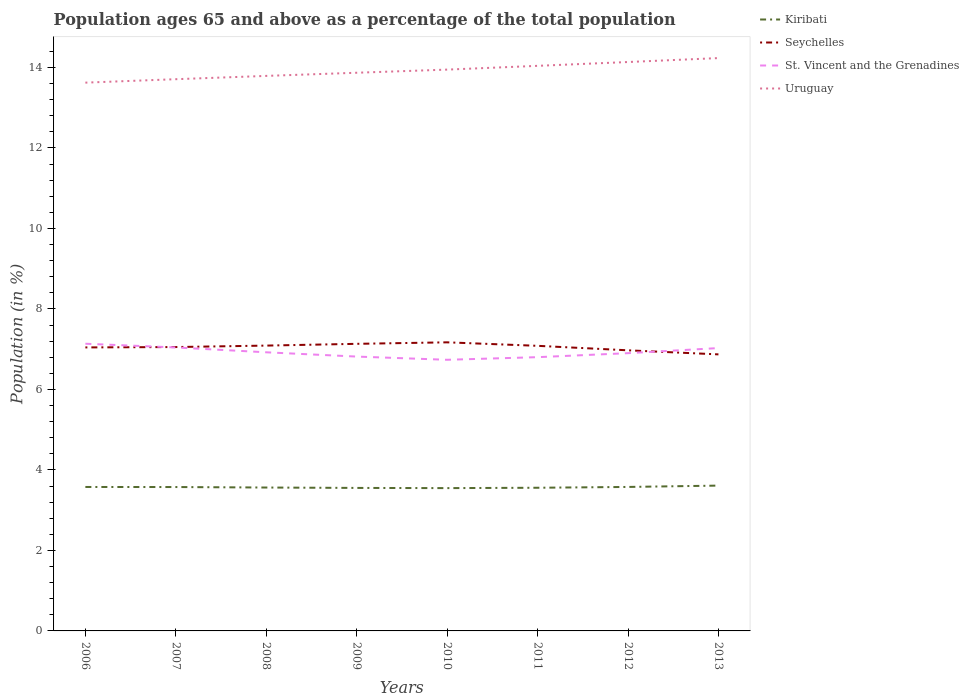Does the line corresponding to St. Vincent and the Grenadines intersect with the line corresponding to Seychelles?
Offer a terse response. Yes. Across all years, what is the maximum percentage of the population ages 65 and above in Seychelles?
Offer a very short reply. 6.87. In which year was the percentage of the population ages 65 and above in Uruguay maximum?
Offer a very short reply. 2006. What is the total percentage of the population ages 65 and above in St. Vincent and the Grenadines in the graph?
Your answer should be very brief. -0.21. What is the difference between the highest and the second highest percentage of the population ages 65 and above in Kiribati?
Make the answer very short. 0.06. Is the percentage of the population ages 65 and above in Uruguay strictly greater than the percentage of the population ages 65 and above in Seychelles over the years?
Offer a very short reply. No. How many lines are there?
Offer a terse response. 4. Does the graph contain grids?
Keep it short and to the point. No. Where does the legend appear in the graph?
Keep it short and to the point. Top right. How many legend labels are there?
Keep it short and to the point. 4. How are the legend labels stacked?
Make the answer very short. Vertical. What is the title of the graph?
Keep it short and to the point. Population ages 65 and above as a percentage of the total population. Does "Canada" appear as one of the legend labels in the graph?
Offer a terse response. No. What is the label or title of the X-axis?
Provide a short and direct response. Years. What is the Population (in %) of Kiribati in 2006?
Your answer should be very brief. 3.58. What is the Population (in %) in Seychelles in 2006?
Give a very brief answer. 7.04. What is the Population (in %) in St. Vincent and the Grenadines in 2006?
Your answer should be compact. 7.14. What is the Population (in %) of Uruguay in 2006?
Offer a terse response. 13.62. What is the Population (in %) in Kiribati in 2007?
Give a very brief answer. 3.57. What is the Population (in %) of Seychelles in 2007?
Offer a terse response. 7.05. What is the Population (in %) of St. Vincent and the Grenadines in 2007?
Offer a very short reply. 7.04. What is the Population (in %) of Uruguay in 2007?
Offer a terse response. 13.71. What is the Population (in %) in Kiribati in 2008?
Ensure brevity in your answer.  3.56. What is the Population (in %) in Seychelles in 2008?
Keep it short and to the point. 7.09. What is the Population (in %) of St. Vincent and the Grenadines in 2008?
Your answer should be very brief. 6.92. What is the Population (in %) in Uruguay in 2008?
Make the answer very short. 13.79. What is the Population (in %) in Kiribati in 2009?
Ensure brevity in your answer.  3.55. What is the Population (in %) in Seychelles in 2009?
Provide a succinct answer. 7.13. What is the Population (in %) of St. Vincent and the Grenadines in 2009?
Make the answer very short. 6.82. What is the Population (in %) in Uruguay in 2009?
Ensure brevity in your answer.  13.87. What is the Population (in %) of Kiribati in 2010?
Offer a very short reply. 3.55. What is the Population (in %) of Seychelles in 2010?
Ensure brevity in your answer.  7.17. What is the Population (in %) of St. Vincent and the Grenadines in 2010?
Your response must be concise. 6.74. What is the Population (in %) of Uruguay in 2010?
Ensure brevity in your answer.  13.95. What is the Population (in %) of Kiribati in 2011?
Offer a very short reply. 3.56. What is the Population (in %) in Seychelles in 2011?
Offer a terse response. 7.08. What is the Population (in %) of St. Vincent and the Grenadines in 2011?
Offer a terse response. 6.8. What is the Population (in %) in Uruguay in 2011?
Offer a very short reply. 14.04. What is the Population (in %) of Kiribati in 2012?
Offer a terse response. 3.58. What is the Population (in %) of Seychelles in 2012?
Give a very brief answer. 6.97. What is the Population (in %) in St. Vincent and the Grenadines in 2012?
Keep it short and to the point. 6.9. What is the Population (in %) in Uruguay in 2012?
Give a very brief answer. 14.13. What is the Population (in %) in Kiribati in 2013?
Your response must be concise. 3.61. What is the Population (in %) in Seychelles in 2013?
Provide a short and direct response. 6.87. What is the Population (in %) in St. Vincent and the Grenadines in 2013?
Make the answer very short. 7.03. What is the Population (in %) in Uruguay in 2013?
Give a very brief answer. 14.23. Across all years, what is the maximum Population (in %) of Kiribati?
Keep it short and to the point. 3.61. Across all years, what is the maximum Population (in %) in Seychelles?
Offer a very short reply. 7.17. Across all years, what is the maximum Population (in %) in St. Vincent and the Grenadines?
Give a very brief answer. 7.14. Across all years, what is the maximum Population (in %) in Uruguay?
Keep it short and to the point. 14.23. Across all years, what is the minimum Population (in %) of Kiribati?
Your answer should be compact. 3.55. Across all years, what is the minimum Population (in %) in Seychelles?
Your answer should be compact. 6.87. Across all years, what is the minimum Population (in %) of St. Vincent and the Grenadines?
Offer a terse response. 6.74. Across all years, what is the minimum Population (in %) in Uruguay?
Give a very brief answer. 13.62. What is the total Population (in %) in Kiribati in the graph?
Offer a very short reply. 28.56. What is the total Population (in %) of Seychelles in the graph?
Your answer should be compact. 56.41. What is the total Population (in %) of St. Vincent and the Grenadines in the graph?
Provide a short and direct response. 55.38. What is the total Population (in %) of Uruguay in the graph?
Offer a terse response. 111.34. What is the difference between the Population (in %) in Kiribati in 2006 and that in 2007?
Your answer should be compact. 0. What is the difference between the Population (in %) in Seychelles in 2006 and that in 2007?
Your response must be concise. -0.01. What is the difference between the Population (in %) in St. Vincent and the Grenadines in 2006 and that in 2007?
Provide a short and direct response. 0.09. What is the difference between the Population (in %) in Uruguay in 2006 and that in 2007?
Make the answer very short. -0.09. What is the difference between the Population (in %) in Kiribati in 2006 and that in 2008?
Keep it short and to the point. 0.01. What is the difference between the Population (in %) of Seychelles in 2006 and that in 2008?
Give a very brief answer. -0.05. What is the difference between the Population (in %) of St. Vincent and the Grenadines in 2006 and that in 2008?
Your response must be concise. 0.21. What is the difference between the Population (in %) of Uruguay in 2006 and that in 2008?
Offer a very short reply. -0.17. What is the difference between the Population (in %) of Kiribati in 2006 and that in 2009?
Provide a succinct answer. 0.02. What is the difference between the Population (in %) in Seychelles in 2006 and that in 2009?
Keep it short and to the point. -0.09. What is the difference between the Population (in %) in St. Vincent and the Grenadines in 2006 and that in 2009?
Offer a terse response. 0.32. What is the difference between the Population (in %) in Uruguay in 2006 and that in 2009?
Your answer should be compact. -0.25. What is the difference between the Population (in %) of Kiribati in 2006 and that in 2010?
Give a very brief answer. 0.03. What is the difference between the Population (in %) in Seychelles in 2006 and that in 2010?
Offer a very short reply. -0.13. What is the difference between the Population (in %) of St. Vincent and the Grenadines in 2006 and that in 2010?
Offer a very short reply. 0.4. What is the difference between the Population (in %) of Uruguay in 2006 and that in 2010?
Ensure brevity in your answer.  -0.32. What is the difference between the Population (in %) of Kiribati in 2006 and that in 2011?
Keep it short and to the point. 0.02. What is the difference between the Population (in %) in Seychelles in 2006 and that in 2011?
Make the answer very short. -0.04. What is the difference between the Population (in %) of St. Vincent and the Grenadines in 2006 and that in 2011?
Make the answer very short. 0.33. What is the difference between the Population (in %) in Uruguay in 2006 and that in 2011?
Your answer should be very brief. -0.42. What is the difference between the Population (in %) in Kiribati in 2006 and that in 2012?
Ensure brevity in your answer.  -0. What is the difference between the Population (in %) of Seychelles in 2006 and that in 2012?
Keep it short and to the point. 0.07. What is the difference between the Population (in %) in St. Vincent and the Grenadines in 2006 and that in 2012?
Provide a succinct answer. 0.23. What is the difference between the Population (in %) of Uruguay in 2006 and that in 2012?
Ensure brevity in your answer.  -0.51. What is the difference between the Population (in %) of Kiribati in 2006 and that in 2013?
Offer a very short reply. -0.03. What is the difference between the Population (in %) in Seychelles in 2006 and that in 2013?
Your answer should be compact. 0.17. What is the difference between the Population (in %) of St. Vincent and the Grenadines in 2006 and that in 2013?
Make the answer very short. 0.11. What is the difference between the Population (in %) in Uruguay in 2006 and that in 2013?
Make the answer very short. -0.61. What is the difference between the Population (in %) in Kiribati in 2007 and that in 2008?
Offer a very short reply. 0.01. What is the difference between the Population (in %) of Seychelles in 2007 and that in 2008?
Your answer should be very brief. -0.04. What is the difference between the Population (in %) of St. Vincent and the Grenadines in 2007 and that in 2008?
Keep it short and to the point. 0.12. What is the difference between the Population (in %) in Uruguay in 2007 and that in 2008?
Offer a terse response. -0.08. What is the difference between the Population (in %) in Kiribati in 2007 and that in 2009?
Ensure brevity in your answer.  0.02. What is the difference between the Population (in %) in Seychelles in 2007 and that in 2009?
Give a very brief answer. -0.08. What is the difference between the Population (in %) of St. Vincent and the Grenadines in 2007 and that in 2009?
Offer a very short reply. 0.23. What is the difference between the Population (in %) in Uruguay in 2007 and that in 2009?
Your answer should be very brief. -0.16. What is the difference between the Population (in %) of Kiribati in 2007 and that in 2010?
Ensure brevity in your answer.  0.03. What is the difference between the Population (in %) in Seychelles in 2007 and that in 2010?
Offer a very short reply. -0.12. What is the difference between the Population (in %) of St. Vincent and the Grenadines in 2007 and that in 2010?
Give a very brief answer. 0.31. What is the difference between the Population (in %) in Uruguay in 2007 and that in 2010?
Your response must be concise. -0.24. What is the difference between the Population (in %) of Kiribati in 2007 and that in 2011?
Offer a very short reply. 0.02. What is the difference between the Population (in %) in Seychelles in 2007 and that in 2011?
Ensure brevity in your answer.  -0.03. What is the difference between the Population (in %) of St. Vincent and the Grenadines in 2007 and that in 2011?
Provide a short and direct response. 0.24. What is the difference between the Population (in %) of Uruguay in 2007 and that in 2011?
Ensure brevity in your answer.  -0.33. What is the difference between the Population (in %) of Kiribati in 2007 and that in 2012?
Keep it short and to the point. -0. What is the difference between the Population (in %) of Seychelles in 2007 and that in 2012?
Ensure brevity in your answer.  0.08. What is the difference between the Population (in %) of St. Vincent and the Grenadines in 2007 and that in 2012?
Provide a short and direct response. 0.14. What is the difference between the Population (in %) of Uruguay in 2007 and that in 2012?
Keep it short and to the point. -0.43. What is the difference between the Population (in %) in Kiribati in 2007 and that in 2013?
Your answer should be very brief. -0.04. What is the difference between the Population (in %) of Seychelles in 2007 and that in 2013?
Keep it short and to the point. 0.18. What is the difference between the Population (in %) in St. Vincent and the Grenadines in 2007 and that in 2013?
Your answer should be compact. 0.02. What is the difference between the Population (in %) in Uruguay in 2007 and that in 2013?
Provide a short and direct response. -0.52. What is the difference between the Population (in %) in Kiribati in 2008 and that in 2009?
Provide a succinct answer. 0.01. What is the difference between the Population (in %) in Seychelles in 2008 and that in 2009?
Make the answer very short. -0.04. What is the difference between the Population (in %) in St. Vincent and the Grenadines in 2008 and that in 2009?
Offer a terse response. 0.11. What is the difference between the Population (in %) of Uruguay in 2008 and that in 2009?
Ensure brevity in your answer.  -0.08. What is the difference between the Population (in %) of Kiribati in 2008 and that in 2010?
Offer a very short reply. 0.01. What is the difference between the Population (in %) in Seychelles in 2008 and that in 2010?
Your answer should be compact. -0.08. What is the difference between the Population (in %) in St. Vincent and the Grenadines in 2008 and that in 2010?
Your response must be concise. 0.19. What is the difference between the Population (in %) in Uruguay in 2008 and that in 2010?
Make the answer very short. -0.16. What is the difference between the Population (in %) of Kiribati in 2008 and that in 2011?
Provide a short and direct response. 0.01. What is the difference between the Population (in %) of Seychelles in 2008 and that in 2011?
Offer a terse response. 0.01. What is the difference between the Population (in %) in St. Vincent and the Grenadines in 2008 and that in 2011?
Keep it short and to the point. 0.12. What is the difference between the Population (in %) in Uruguay in 2008 and that in 2011?
Your answer should be very brief. -0.25. What is the difference between the Population (in %) of Kiribati in 2008 and that in 2012?
Give a very brief answer. -0.01. What is the difference between the Population (in %) of Seychelles in 2008 and that in 2012?
Ensure brevity in your answer.  0.12. What is the difference between the Population (in %) of St. Vincent and the Grenadines in 2008 and that in 2012?
Offer a terse response. 0.02. What is the difference between the Population (in %) in Uruguay in 2008 and that in 2012?
Your answer should be compact. -0.34. What is the difference between the Population (in %) in Kiribati in 2008 and that in 2013?
Your response must be concise. -0.05. What is the difference between the Population (in %) in Seychelles in 2008 and that in 2013?
Give a very brief answer. 0.22. What is the difference between the Population (in %) of St. Vincent and the Grenadines in 2008 and that in 2013?
Your answer should be very brief. -0.1. What is the difference between the Population (in %) of Uruguay in 2008 and that in 2013?
Ensure brevity in your answer.  -0.44. What is the difference between the Population (in %) of Kiribati in 2009 and that in 2010?
Ensure brevity in your answer.  0. What is the difference between the Population (in %) in Seychelles in 2009 and that in 2010?
Give a very brief answer. -0.04. What is the difference between the Population (in %) in St. Vincent and the Grenadines in 2009 and that in 2010?
Provide a short and direct response. 0.08. What is the difference between the Population (in %) in Uruguay in 2009 and that in 2010?
Make the answer very short. -0.08. What is the difference between the Population (in %) of Kiribati in 2009 and that in 2011?
Ensure brevity in your answer.  -0. What is the difference between the Population (in %) in Seychelles in 2009 and that in 2011?
Provide a succinct answer. 0.05. What is the difference between the Population (in %) of St. Vincent and the Grenadines in 2009 and that in 2011?
Ensure brevity in your answer.  0.01. What is the difference between the Population (in %) of Uruguay in 2009 and that in 2011?
Ensure brevity in your answer.  -0.17. What is the difference between the Population (in %) of Kiribati in 2009 and that in 2012?
Ensure brevity in your answer.  -0.02. What is the difference between the Population (in %) of Seychelles in 2009 and that in 2012?
Give a very brief answer. 0.16. What is the difference between the Population (in %) in St. Vincent and the Grenadines in 2009 and that in 2012?
Give a very brief answer. -0.08. What is the difference between the Population (in %) in Uruguay in 2009 and that in 2012?
Offer a terse response. -0.27. What is the difference between the Population (in %) of Kiribati in 2009 and that in 2013?
Your answer should be compact. -0.06. What is the difference between the Population (in %) in Seychelles in 2009 and that in 2013?
Your answer should be very brief. 0.26. What is the difference between the Population (in %) of St. Vincent and the Grenadines in 2009 and that in 2013?
Your answer should be very brief. -0.21. What is the difference between the Population (in %) of Uruguay in 2009 and that in 2013?
Provide a short and direct response. -0.36. What is the difference between the Population (in %) in Kiribati in 2010 and that in 2011?
Offer a very short reply. -0.01. What is the difference between the Population (in %) of Seychelles in 2010 and that in 2011?
Your response must be concise. 0.09. What is the difference between the Population (in %) in St. Vincent and the Grenadines in 2010 and that in 2011?
Ensure brevity in your answer.  -0.07. What is the difference between the Population (in %) in Uruguay in 2010 and that in 2011?
Your answer should be compact. -0.09. What is the difference between the Population (in %) of Kiribati in 2010 and that in 2012?
Ensure brevity in your answer.  -0.03. What is the difference between the Population (in %) in Seychelles in 2010 and that in 2012?
Your response must be concise. 0.2. What is the difference between the Population (in %) of St. Vincent and the Grenadines in 2010 and that in 2012?
Your answer should be very brief. -0.16. What is the difference between the Population (in %) of Uruguay in 2010 and that in 2012?
Offer a terse response. -0.19. What is the difference between the Population (in %) of Kiribati in 2010 and that in 2013?
Your answer should be compact. -0.06. What is the difference between the Population (in %) in Seychelles in 2010 and that in 2013?
Your answer should be compact. 0.3. What is the difference between the Population (in %) of St. Vincent and the Grenadines in 2010 and that in 2013?
Make the answer very short. -0.29. What is the difference between the Population (in %) of Uruguay in 2010 and that in 2013?
Your answer should be compact. -0.29. What is the difference between the Population (in %) of Kiribati in 2011 and that in 2012?
Ensure brevity in your answer.  -0.02. What is the difference between the Population (in %) in Seychelles in 2011 and that in 2012?
Make the answer very short. 0.11. What is the difference between the Population (in %) of St. Vincent and the Grenadines in 2011 and that in 2012?
Offer a very short reply. -0.1. What is the difference between the Population (in %) in Uruguay in 2011 and that in 2012?
Your answer should be compact. -0.1. What is the difference between the Population (in %) of Kiribati in 2011 and that in 2013?
Your answer should be compact. -0.05. What is the difference between the Population (in %) of Seychelles in 2011 and that in 2013?
Your answer should be very brief. 0.21. What is the difference between the Population (in %) of St. Vincent and the Grenadines in 2011 and that in 2013?
Offer a terse response. -0.23. What is the difference between the Population (in %) of Uruguay in 2011 and that in 2013?
Provide a succinct answer. -0.19. What is the difference between the Population (in %) in Kiribati in 2012 and that in 2013?
Your answer should be compact. -0.03. What is the difference between the Population (in %) of Seychelles in 2012 and that in 2013?
Offer a terse response. 0.1. What is the difference between the Population (in %) of St. Vincent and the Grenadines in 2012 and that in 2013?
Make the answer very short. -0.13. What is the difference between the Population (in %) in Uruguay in 2012 and that in 2013?
Your answer should be compact. -0.1. What is the difference between the Population (in %) in Kiribati in 2006 and the Population (in %) in Seychelles in 2007?
Make the answer very short. -3.48. What is the difference between the Population (in %) of Kiribati in 2006 and the Population (in %) of St. Vincent and the Grenadines in 2007?
Make the answer very short. -3.47. What is the difference between the Population (in %) of Kiribati in 2006 and the Population (in %) of Uruguay in 2007?
Provide a short and direct response. -10.13. What is the difference between the Population (in %) in Seychelles in 2006 and the Population (in %) in St. Vincent and the Grenadines in 2007?
Offer a terse response. 0. What is the difference between the Population (in %) in Seychelles in 2006 and the Population (in %) in Uruguay in 2007?
Provide a succinct answer. -6.66. What is the difference between the Population (in %) in St. Vincent and the Grenadines in 2006 and the Population (in %) in Uruguay in 2007?
Make the answer very short. -6.57. What is the difference between the Population (in %) in Kiribati in 2006 and the Population (in %) in Seychelles in 2008?
Your answer should be compact. -3.51. What is the difference between the Population (in %) in Kiribati in 2006 and the Population (in %) in St. Vincent and the Grenadines in 2008?
Offer a very short reply. -3.35. What is the difference between the Population (in %) of Kiribati in 2006 and the Population (in %) of Uruguay in 2008?
Make the answer very short. -10.21. What is the difference between the Population (in %) in Seychelles in 2006 and the Population (in %) in St. Vincent and the Grenadines in 2008?
Your response must be concise. 0.12. What is the difference between the Population (in %) in Seychelles in 2006 and the Population (in %) in Uruguay in 2008?
Offer a terse response. -6.75. What is the difference between the Population (in %) of St. Vincent and the Grenadines in 2006 and the Population (in %) of Uruguay in 2008?
Give a very brief answer. -6.65. What is the difference between the Population (in %) of Kiribati in 2006 and the Population (in %) of Seychelles in 2009?
Offer a very short reply. -3.56. What is the difference between the Population (in %) of Kiribati in 2006 and the Population (in %) of St. Vincent and the Grenadines in 2009?
Your answer should be compact. -3.24. What is the difference between the Population (in %) of Kiribati in 2006 and the Population (in %) of Uruguay in 2009?
Keep it short and to the point. -10.29. What is the difference between the Population (in %) in Seychelles in 2006 and the Population (in %) in St. Vincent and the Grenadines in 2009?
Give a very brief answer. 0.23. What is the difference between the Population (in %) in Seychelles in 2006 and the Population (in %) in Uruguay in 2009?
Offer a terse response. -6.82. What is the difference between the Population (in %) of St. Vincent and the Grenadines in 2006 and the Population (in %) of Uruguay in 2009?
Offer a terse response. -6.73. What is the difference between the Population (in %) in Kiribati in 2006 and the Population (in %) in Seychelles in 2010?
Your answer should be very brief. -3.59. What is the difference between the Population (in %) of Kiribati in 2006 and the Population (in %) of St. Vincent and the Grenadines in 2010?
Offer a terse response. -3.16. What is the difference between the Population (in %) of Kiribati in 2006 and the Population (in %) of Uruguay in 2010?
Give a very brief answer. -10.37. What is the difference between the Population (in %) of Seychelles in 2006 and the Population (in %) of St. Vincent and the Grenadines in 2010?
Provide a short and direct response. 0.31. What is the difference between the Population (in %) in Seychelles in 2006 and the Population (in %) in Uruguay in 2010?
Your answer should be compact. -6.9. What is the difference between the Population (in %) of St. Vincent and the Grenadines in 2006 and the Population (in %) of Uruguay in 2010?
Offer a terse response. -6.81. What is the difference between the Population (in %) in Kiribati in 2006 and the Population (in %) in Seychelles in 2011?
Provide a succinct answer. -3.51. What is the difference between the Population (in %) of Kiribati in 2006 and the Population (in %) of St. Vincent and the Grenadines in 2011?
Offer a very short reply. -3.23. What is the difference between the Population (in %) of Kiribati in 2006 and the Population (in %) of Uruguay in 2011?
Offer a terse response. -10.46. What is the difference between the Population (in %) of Seychelles in 2006 and the Population (in %) of St. Vincent and the Grenadines in 2011?
Offer a terse response. 0.24. What is the difference between the Population (in %) in Seychelles in 2006 and the Population (in %) in Uruguay in 2011?
Keep it short and to the point. -7. What is the difference between the Population (in %) of St. Vincent and the Grenadines in 2006 and the Population (in %) of Uruguay in 2011?
Ensure brevity in your answer.  -6.9. What is the difference between the Population (in %) in Kiribati in 2006 and the Population (in %) in Seychelles in 2012?
Provide a short and direct response. -3.4. What is the difference between the Population (in %) in Kiribati in 2006 and the Population (in %) in St. Vincent and the Grenadines in 2012?
Provide a succinct answer. -3.32. What is the difference between the Population (in %) of Kiribati in 2006 and the Population (in %) of Uruguay in 2012?
Your answer should be very brief. -10.56. What is the difference between the Population (in %) in Seychelles in 2006 and the Population (in %) in St. Vincent and the Grenadines in 2012?
Your response must be concise. 0.14. What is the difference between the Population (in %) in Seychelles in 2006 and the Population (in %) in Uruguay in 2012?
Provide a short and direct response. -7.09. What is the difference between the Population (in %) of St. Vincent and the Grenadines in 2006 and the Population (in %) of Uruguay in 2012?
Your response must be concise. -7. What is the difference between the Population (in %) in Kiribati in 2006 and the Population (in %) in Seychelles in 2013?
Your answer should be compact. -3.29. What is the difference between the Population (in %) in Kiribati in 2006 and the Population (in %) in St. Vincent and the Grenadines in 2013?
Offer a terse response. -3.45. What is the difference between the Population (in %) of Kiribati in 2006 and the Population (in %) of Uruguay in 2013?
Offer a very short reply. -10.66. What is the difference between the Population (in %) of Seychelles in 2006 and the Population (in %) of St. Vincent and the Grenadines in 2013?
Your answer should be compact. 0.02. What is the difference between the Population (in %) in Seychelles in 2006 and the Population (in %) in Uruguay in 2013?
Provide a succinct answer. -7.19. What is the difference between the Population (in %) in St. Vincent and the Grenadines in 2006 and the Population (in %) in Uruguay in 2013?
Offer a terse response. -7.1. What is the difference between the Population (in %) in Kiribati in 2007 and the Population (in %) in Seychelles in 2008?
Provide a succinct answer. -3.51. What is the difference between the Population (in %) of Kiribati in 2007 and the Population (in %) of St. Vincent and the Grenadines in 2008?
Provide a short and direct response. -3.35. What is the difference between the Population (in %) of Kiribati in 2007 and the Population (in %) of Uruguay in 2008?
Your answer should be compact. -10.21. What is the difference between the Population (in %) in Seychelles in 2007 and the Population (in %) in St. Vincent and the Grenadines in 2008?
Your response must be concise. 0.13. What is the difference between the Population (in %) of Seychelles in 2007 and the Population (in %) of Uruguay in 2008?
Give a very brief answer. -6.74. What is the difference between the Population (in %) in St. Vincent and the Grenadines in 2007 and the Population (in %) in Uruguay in 2008?
Your response must be concise. -6.75. What is the difference between the Population (in %) of Kiribati in 2007 and the Population (in %) of Seychelles in 2009?
Make the answer very short. -3.56. What is the difference between the Population (in %) of Kiribati in 2007 and the Population (in %) of St. Vincent and the Grenadines in 2009?
Provide a succinct answer. -3.24. What is the difference between the Population (in %) of Kiribati in 2007 and the Population (in %) of Uruguay in 2009?
Offer a terse response. -10.29. What is the difference between the Population (in %) of Seychelles in 2007 and the Population (in %) of St. Vincent and the Grenadines in 2009?
Keep it short and to the point. 0.24. What is the difference between the Population (in %) of Seychelles in 2007 and the Population (in %) of Uruguay in 2009?
Your answer should be compact. -6.82. What is the difference between the Population (in %) of St. Vincent and the Grenadines in 2007 and the Population (in %) of Uruguay in 2009?
Keep it short and to the point. -6.83. What is the difference between the Population (in %) in Kiribati in 2007 and the Population (in %) in Seychelles in 2010?
Provide a succinct answer. -3.6. What is the difference between the Population (in %) of Kiribati in 2007 and the Population (in %) of St. Vincent and the Grenadines in 2010?
Give a very brief answer. -3.16. What is the difference between the Population (in %) in Kiribati in 2007 and the Population (in %) in Uruguay in 2010?
Your answer should be compact. -10.37. What is the difference between the Population (in %) in Seychelles in 2007 and the Population (in %) in St. Vincent and the Grenadines in 2010?
Your answer should be compact. 0.32. What is the difference between the Population (in %) in Seychelles in 2007 and the Population (in %) in Uruguay in 2010?
Offer a very short reply. -6.89. What is the difference between the Population (in %) of St. Vincent and the Grenadines in 2007 and the Population (in %) of Uruguay in 2010?
Your answer should be very brief. -6.9. What is the difference between the Population (in %) in Kiribati in 2007 and the Population (in %) in Seychelles in 2011?
Your response must be concise. -3.51. What is the difference between the Population (in %) in Kiribati in 2007 and the Population (in %) in St. Vincent and the Grenadines in 2011?
Provide a succinct answer. -3.23. What is the difference between the Population (in %) of Kiribati in 2007 and the Population (in %) of Uruguay in 2011?
Your answer should be very brief. -10.46. What is the difference between the Population (in %) of Seychelles in 2007 and the Population (in %) of St. Vincent and the Grenadines in 2011?
Ensure brevity in your answer.  0.25. What is the difference between the Population (in %) of Seychelles in 2007 and the Population (in %) of Uruguay in 2011?
Your answer should be compact. -6.99. What is the difference between the Population (in %) in St. Vincent and the Grenadines in 2007 and the Population (in %) in Uruguay in 2011?
Your response must be concise. -7. What is the difference between the Population (in %) in Kiribati in 2007 and the Population (in %) in Seychelles in 2012?
Keep it short and to the point. -3.4. What is the difference between the Population (in %) of Kiribati in 2007 and the Population (in %) of St. Vincent and the Grenadines in 2012?
Give a very brief answer. -3.33. What is the difference between the Population (in %) in Kiribati in 2007 and the Population (in %) in Uruguay in 2012?
Ensure brevity in your answer.  -10.56. What is the difference between the Population (in %) of Seychelles in 2007 and the Population (in %) of St. Vincent and the Grenadines in 2012?
Provide a short and direct response. 0.15. What is the difference between the Population (in %) in Seychelles in 2007 and the Population (in %) in Uruguay in 2012?
Keep it short and to the point. -7.08. What is the difference between the Population (in %) of St. Vincent and the Grenadines in 2007 and the Population (in %) of Uruguay in 2012?
Provide a succinct answer. -7.09. What is the difference between the Population (in %) in Kiribati in 2007 and the Population (in %) in Seychelles in 2013?
Make the answer very short. -3.3. What is the difference between the Population (in %) in Kiribati in 2007 and the Population (in %) in St. Vincent and the Grenadines in 2013?
Your answer should be very brief. -3.45. What is the difference between the Population (in %) of Kiribati in 2007 and the Population (in %) of Uruguay in 2013?
Offer a terse response. -10.66. What is the difference between the Population (in %) in Seychelles in 2007 and the Population (in %) in St. Vincent and the Grenadines in 2013?
Your answer should be compact. 0.03. What is the difference between the Population (in %) in Seychelles in 2007 and the Population (in %) in Uruguay in 2013?
Ensure brevity in your answer.  -7.18. What is the difference between the Population (in %) in St. Vincent and the Grenadines in 2007 and the Population (in %) in Uruguay in 2013?
Your answer should be compact. -7.19. What is the difference between the Population (in %) in Kiribati in 2008 and the Population (in %) in Seychelles in 2009?
Ensure brevity in your answer.  -3.57. What is the difference between the Population (in %) of Kiribati in 2008 and the Population (in %) of St. Vincent and the Grenadines in 2009?
Your answer should be compact. -3.25. What is the difference between the Population (in %) of Kiribati in 2008 and the Population (in %) of Uruguay in 2009?
Ensure brevity in your answer.  -10.31. What is the difference between the Population (in %) of Seychelles in 2008 and the Population (in %) of St. Vincent and the Grenadines in 2009?
Your answer should be very brief. 0.27. What is the difference between the Population (in %) in Seychelles in 2008 and the Population (in %) in Uruguay in 2009?
Offer a very short reply. -6.78. What is the difference between the Population (in %) in St. Vincent and the Grenadines in 2008 and the Population (in %) in Uruguay in 2009?
Keep it short and to the point. -6.95. What is the difference between the Population (in %) of Kiribati in 2008 and the Population (in %) of Seychelles in 2010?
Your response must be concise. -3.61. What is the difference between the Population (in %) in Kiribati in 2008 and the Population (in %) in St. Vincent and the Grenadines in 2010?
Provide a succinct answer. -3.17. What is the difference between the Population (in %) in Kiribati in 2008 and the Population (in %) in Uruguay in 2010?
Offer a terse response. -10.38. What is the difference between the Population (in %) of Seychelles in 2008 and the Population (in %) of St. Vincent and the Grenadines in 2010?
Keep it short and to the point. 0.35. What is the difference between the Population (in %) in Seychelles in 2008 and the Population (in %) in Uruguay in 2010?
Make the answer very short. -6.86. What is the difference between the Population (in %) in St. Vincent and the Grenadines in 2008 and the Population (in %) in Uruguay in 2010?
Your answer should be compact. -7.02. What is the difference between the Population (in %) in Kiribati in 2008 and the Population (in %) in Seychelles in 2011?
Your response must be concise. -3.52. What is the difference between the Population (in %) in Kiribati in 2008 and the Population (in %) in St. Vincent and the Grenadines in 2011?
Provide a succinct answer. -3.24. What is the difference between the Population (in %) in Kiribati in 2008 and the Population (in %) in Uruguay in 2011?
Ensure brevity in your answer.  -10.48. What is the difference between the Population (in %) of Seychelles in 2008 and the Population (in %) of St. Vincent and the Grenadines in 2011?
Make the answer very short. 0.29. What is the difference between the Population (in %) of Seychelles in 2008 and the Population (in %) of Uruguay in 2011?
Offer a very short reply. -6.95. What is the difference between the Population (in %) in St. Vincent and the Grenadines in 2008 and the Population (in %) in Uruguay in 2011?
Your answer should be compact. -7.12. What is the difference between the Population (in %) of Kiribati in 2008 and the Population (in %) of Seychelles in 2012?
Ensure brevity in your answer.  -3.41. What is the difference between the Population (in %) in Kiribati in 2008 and the Population (in %) in St. Vincent and the Grenadines in 2012?
Make the answer very short. -3.34. What is the difference between the Population (in %) in Kiribati in 2008 and the Population (in %) in Uruguay in 2012?
Offer a very short reply. -10.57. What is the difference between the Population (in %) in Seychelles in 2008 and the Population (in %) in St. Vincent and the Grenadines in 2012?
Provide a succinct answer. 0.19. What is the difference between the Population (in %) of Seychelles in 2008 and the Population (in %) of Uruguay in 2012?
Provide a short and direct response. -7.05. What is the difference between the Population (in %) of St. Vincent and the Grenadines in 2008 and the Population (in %) of Uruguay in 2012?
Offer a very short reply. -7.21. What is the difference between the Population (in %) of Kiribati in 2008 and the Population (in %) of Seychelles in 2013?
Give a very brief answer. -3.31. What is the difference between the Population (in %) of Kiribati in 2008 and the Population (in %) of St. Vincent and the Grenadines in 2013?
Your answer should be compact. -3.46. What is the difference between the Population (in %) in Kiribati in 2008 and the Population (in %) in Uruguay in 2013?
Your response must be concise. -10.67. What is the difference between the Population (in %) in Seychelles in 2008 and the Population (in %) in St. Vincent and the Grenadines in 2013?
Make the answer very short. 0.06. What is the difference between the Population (in %) in Seychelles in 2008 and the Population (in %) in Uruguay in 2013?
Your response must be concise. -7.14. What is the difference between the Population (in %) of St. Vincent and the Grenadines in 2008 and the Population (in %) of Uruguay in 2013?
Your response must be concise. -7.31. What is the difference between the Population (in %) of Kiribati in 2009 and the Population (in %) of Seychelles in 2010?
Offer a terse response. -3.62. What is the difference between the Population (in %) of Kiribati in 2009 and the Population (in %) of St. Vincent and the Grenadines in 2010?
Your response must be concise. -3.18. What is the difference between the Population (in %) in Kiribati in 2009 and the Population (in %) in Uruguay in 2010?
Ensure brevity in your answer.  -10.39. What is the difference between the Population (in %) of Seychelles in 2009 and the Population (in %) of St. Vincent and the Grenadines in 2010?
Ensure brevity in your answer.  0.4. What is the difference between the Population (in %) of Seychelles in 2009 and the Population (in %) of Uruguay in 2010?
Provide a short and direct response. -6.81. What is the difference between the Population (in %) in St. Vincent and the Grenadines in 2009 and the Population (in %) in Uruguay in 2010?
Give a very brief answer. -7.13. What is the difference between the Population (in %) in Kiribati in 2009 and the Population (in %) in Seychelles in 2011?
Make the answer very short. -3.53. What is the difference between the Population (in %) of Kiribati in 2009 and the Population (in %) of St. Vincent and the Grenadines in 2011?
Your answer should be very brief. -3.25. What is the difference between the Population (in %) in Kiribati in 2009 and the Population (in %) in Uruguay in 2011?
Offer a terse response. -10.49. What is the difference between the Population (in %) in Seychelles in 2009 and the Population (in %) in St. Vincent and the Grenadines in 2011?
Keep it short and to the point. 0.33. What is the difference between the Population (in %) of Seychelles in 2009 and the Population (in %) of Uruguay in 2011?
Keep it short and to the point. -6.91. What is the difference between the Population (in %) of St. Vincent and the Grenadines in 2009 and the Population (in %) of Uruguay in 2011?
Provide a short and direct response. -7.22. What is the difference between the Population (in %) in Kiribati in 2009 and the Population (in %) in Seychelles in 2012?
Provide a succinct answer. -3.42. What is the difference between the Population (in %) of Kiribati in 2009 and the Population (in %) of St. Vincent and the Grenadines in 2012?
Offer a terse response. -3.35. What is the difference between the Population (in %) of Kiribati in 2009 and the Population (in %) of Uruguay in 2012?
Give a very brief answer. -10.58. What is the difference between the Population (in %) in Seychelles in 2009 and the Population (in %) in St. Vincent and the Grenadines in 2012?
Ensure brevity in your answer.  0.23. What is the difference between the Population (in %) in Seychelles in 2009 and the Population (in %) in Uruguay in 2012?
Your answer should be very brief. -7. What is the difference between the Population (in %) of St. Vincent and the Grenadines in 2009 and the Population (in %) of Uruguay in 2012?
Give a very brief answer. -7.32. What is the difference between the Population (in %) in Kiribati in 2009 and the Population (in %) in Seychelles in 2013?
Offer a terse response. -3.32. What is the difference between the Population (in %) in Kiribati in 2009 and the Population (in %) in St. Vincent and the Grenadines in 2013?
Ensure brevity in your answer.  -3.47. What is the difference between the Population (in %) of Kiribati in 2009 and the Population (in %) of Uruguay in 2013?
Give a very brief answer. -10.68. What is the difference between the Population (in %) of Seychelles in 2009 and the Population (in %) of St. Vincent and the Grenadines in 2013?
Provide a succinct answer. 0.11. What is the difference between the Population (in %) of Seychelles in 2009 and the Population (in %) of Uruguay in 2013?
Give a very brief answer. -7.1. What is the difference between the Population (in %) of St. Vincent and the Grenadines in 2009 and the Population (in %) of Uruguay in 2013?
Make the answer very short. -7.42. What is the difference between the Population (in %) of Kiribati in 2010 and the Population (in %) of Seychelles in 2011?
Keep it short and to the point. -3.54. What is the difference between the Population (in %) of Kiribati in 2010 and the Population (in %) of St. Vincent and the Grenadines in 2011?
Offer a terse response. -3.25. What is the difference between the Population (in %) of Kiribati in 2010 and the Population (in %) of Uruguay in 2011?
Provide a short and direct response. -10.49. What is the difference between the Population (in %) in Seychelles in 2010 and the Population (in %) in St. Vincent and the Grenadines in 2011?
Make the answer very short. 0.37. What is the difference between the Population (in %) in Seychelles in 2010 and the Population (in %) in Uruguay in 2011?
Your answer should be very brief. -6.87. What is the difference between the Population (in %) in St. Vincent and the Grenadines in 2010 and the Population (in %) in Uruguay in 2011?
Provide a short and direct response. -7.3. What is the difference between the Population (in %) in Kiribati in 2010 and the Population (in %) in Seychelles in 2012?
Offer a very short reply. -3.42. What is the difference between the Population (in %) of Kiribati in 2010 and the Population (in %) of St. Vincent and the Grenadines in 2012?
Keep it short and to the point. -3.35. What is the difference between the Population (in %) of Kiribati in 2010 and the Population (in %) of Uruguay in 2012?
Give a very brief answer. -10.59. What is the difference between the Population (in %) in Seychelles in 2010 and the Population (in %) in St. Vincent and the Grenadines in 2012?
Keep it short and to the point. 0.27. What is the difference between the Population (in %) of Seychelles in 2010 and the Population (in %) of Uruguay in 2012?
Keep it short and to the point. -6.96. What is the difference between the Population (in %) in St. Vincent and the Grenadines in 2010 and the Population (in %) in Uruguay in 2012?
Offer a terse response. -7.4. What is the difference between the Population (in %) in Kiribati in 2010 and the Population (in %) in Seychelles in 2013?
Offer a terse response. -3.32. What is the difference between the Population (in %) of Kiribati in 2010 and the Population (in %) of St. Vincent and the Grenadines in 2013?
Ensure brevity in your answer.  -3.48. What is the difference between the Population (in %) of Kiribati in 2010 and the Population (in %) of Uruguay in 2013?
Make the answer very short. -10.68. What is the difference between the Population (in %) in Seychelles in 2010 and the Population (in %) in St. Vincent and the Grenadines in 2013?
Offer a very short reply. 0.14. What is the difference between the Population (in %) of Seychelles in 2010 and the Population (in %) of Uruguay in 2013?
Offer a terse response. -7.06. What is the difference between the Population (in %) in St. Vincent and the Grenadines in 2010 and the Population (in %) in Uruguay in 2013?
Keep it short and to the point. -7.5. What is the difference between the Population (in %) of Kiribati in 2011 and the Population (in %) of Seychelles in 2012?
Offer a very short reply. -3.41. What is the difference between the Population (in %) in Kiribati in 2011 and the Population (in %) in St. Vincent and the Grenadines in 2012?
Your response must be concise. -3.34. What is the difference between the Population (in %) in Kiribati in 2011 and the Population (in %) in Uruguay in 2012?
Make the answer very short. -10.58. What is the difference between the Population (in %) in Seychelles in 2011 and the Population (in %) in St. Vincent and the Grenadines in 2012?
Provide a short and direct response. 0.18. What is the difference between the Population (in %) in Seychelles in 2011 and the Population (in %) in Uruguay in 2012?
Your answer should be very brief. -7.05. What is the difference between the Population (in %) in St. Vincent and the Grenadines in 2011 and the Population (in %) in Uruguay in 2012?
Make the answer very short. -7.33. What is the difference between the Population (in %) of Kiribati in 2011 and the Population (in %) of Seychelles in 2013?
Make the answer very short. -3.31. What is the difference between the Population (in %) in Kiribati in 2011 and the Population (in %) in St. Vincent and the Grenadines in 2013?
Your answer should be very brief. -3.47. What is the difference between the Population (in %) in Kiribati in 2011 and the Population (in %) in Uruguay in 2013?
Your response must be concise. -10.68. What is the difference between the Population (in %) in Seychelles in 2011 and the Population (in %) in St. Vincent and the Grenadines in 2013?
Ensure brevity in your answer.  0.06. What is the difference between the Population (in %) in Seychelles in 2011 and the Population (in %) in Uruguay in 2013?
Offer a terse response. -7.15. What is the difference between the Population (in %) of St. Vincent and the Grenadines in 2011 and the Population (in %) of Uruguay in 2013?
Keep it short and to the point. -7.43. What is the difference between the Population (in %) of Kiribati in 2012 and the Population (in %) of Seychelles in 2013?
Provide a short and direct response. -3.29. What is the difference between the Population (in %) of Kiribati in 2012 and the Population (in %) of St. Vincent and the Grenadines in 2013?
Offer a very short reply. -3.45. What is the difference between the Population (in %) of Kiribati in 2012 and the Population (in %) of Uruguay in 2013?
Give a very brief answer. -10.66. What is the difference between the Population (in %) of Seychelles in 2012 and the Population (in %) of St. Vincent and the Grenadines in 2013?
Offer a terse response. -0.06. What is the difference between the Population (in %) of Seychelles in 2012 and the Population (in %) of Uruguay in 2013?
Make the answer very short. -7.26. What is the difference between the Population (in %) in St. Vincent and the Grenadines in 2012 and the Population (in %) in Uruguay in 2013?
Provide a short and direct response. -7.33. What is the average Population (in %) in Kiribati per year?
Give a very brief answer. 3.57. What is the average Population (in %) in Seychelles per year?
Give a very brief answer. 7.05. What is the average Population (in %) in St. Vincent and the Grenadines per year?
Ensure brevity in your answer.  6.92. What is the average Population (in %) of Uruguay per year?
Ensure brevity in your answer.  13.92. In the year 2006, what is the difference between the Population (in %) of Kiribati and Population (in %) of Seychelles?
Give a very brief answer. -3.47. In the year 2006, what is the difference between the Population (in %) in Kiribati and Population (in %) in St. Vincent and the Grenadines?
Offer a terse response. -3.56. In the year 2006, what is the difference between the Population (in %) of Kiribati and Population (in %) of Uruguay?
Keep it short and to the point. -10.05. In the year 2006, what is the difference between the Population (in %) in Seychelles and Population (in %) in St. Vincent and the Grenadines?
Offer a terse response. -0.09. In the year 2006, what is the difference between the Population (in %) in Seychelles and Population (in %) in Uruguay?
Your answer should be very brief. -6.58. In the year 2006, what is the difference between the Population (in %) of St. Vincent and the Grenadines and Population (in %) of Uruguay?
Your answer should be compact. -6.49. In the year 2007, what is the difference between the Population (in %) in Kiribati and Population (in %) in Seychelles?
Provide a succinct answer. -3.48. In the year 2007, what is the difference between the Population (in %) in Kiribati and Population (in %) in St. Vincent and the Grenadines?
Provide a succinct answer. -3.47. In the year 2007, what is the difference between the Population (in %) of Kiribati and Population (in %) of Uruguay?
Give a very brief answer. -10.13. In the year 2007, what is the difference between the Population (in %) of Seychelles and Population (in %) of St. Vincent and the Grenadines?
Offer a terse response. 0.01. In the year 2007, what is the difference between the Population (in %) in Seychelles and Population (in %) in Uruguay?
Your response must be concise. -6.65. In the year 2007, what is the difference between the Population (in %) of St. Vincent and the Grenadines and Population (in %) of Uruguay?
Make the answer very short. -6.67. In the year 2008, what is the difference between the Population (in %) of Kiribati and Population (in %) of Seychelles?
Your answer should be compact. -3.53. In the year 2008, what is the difference between the Population (in %) in Kiribati and Population (in %) in St. Vincent and the Grenadines?
Your answer should be very brief. -3.36. In the year 2008, what is the difference between the Population (in %) of Kiribati and Population (in %) of Uruguay?
Your answer should be compact. -10.23. In the year 2008, what is the difference between the Population (in %) in Seychelles and Population (in %) in St. Vincent and the Grenadines?
Your response must be concise. 0.17. In the year 2008, what is the difference between the Population (in %) in Seychelles and Population (in %) in Uruguay?
Your answer should be compact. -6.7. In the year 2008, what is the difference between the Population (in %) in St. Vincent and the Grenadines and Population (in %) in Uruguay?
Your answer should be very brief. -6.87. In the year 2009, what is the difference between the Population (in %) of Kiribati and Population (in %) of Seychelles?
Ensure brevity in your answer.  -3.58. In the year 2009, what is the difference between the Population (in %) of Kiribati and Population (in %) of St. Vincent and the Grenadines?
Your response must be concise. -3.26. In the year 2009, what is the difference between the Population (in %) of Kiribati and Population (in %) of Uruguay?
Make the answer very short. -10.32. In the year 2009, what is the difference between the Population (in %) of Seychelles and Population (in %) of St. Vincent and the Grenadines?
Offer a terse response. 0.32. In the year 2009, what is the difference between the Population (in %) of Seychelles and Population (in %) of Uruguay?
Your answer should be very brief. -6.74. In the year 2009, what is the difference between the Population (in %) in St. Vincent and the Grenadines and Population (in %) in Uruguay?
Provide a succinct answer. -7.05. In the year 2010, what is the difference between the Population (in %) of Kiribati and Population (in %) of Seychelles?
Ensure brevity in your answer.  -3.62. In the year 2010, what is the difference between the Population (in %) in Kiribati and Population (in %) in St. Vincent and the Grenadines?
Offer a very short reply. -3.19. In the year 2010, what is the difference between the Population (in %) of Kiribati and Population (in %) of Uruguay?
Offer a terse response. -10.4. In the year 2010, what is the difference between the Population (in %) of Seychelles and Population (in %) of St. Vincent and the Grenadines?
Offer a very short reply. 0.43. In the year 2010, what is the difference between the Population (in %) in Seychelles and Population (in %) in Uruguay?
Your answer should be compact. -6.78. In the year 2010, what is the difference between the Population (in %) of St. Vincent and the Grenadines and Population (in %) of Uruguay?
Make the answer very short. -7.21. In the year 2011, what is the difference between the Population (in %) in Kiribati and Population (in %) in Seychelles?
Provide a succinct answer. -3.53. In the year 2011, what is the difference between the Population (in %) in Kiribati and Population (in %) in St. Vincent and the Grenadines?
Make the answer very short. -3.24. In the year 2011, what is the difference between the Population (in %) in Kiribati and Population (in %) in Uruguay?
Give a very brief answer. -10.48. In the year 2011, what is the difference between the Population (in %) in Seychelles and Population (in %) in St. Vincent and the Grenadines?
Offer a terse response. 0.28. In the year 2011, what is the difference between the Population (in %) in Seychelles and Population (in %) in Uruguay?
Offer a very short reply. -6.96. In the year 2011, what is the difference between the Population (in %) in St. Vincent and the Grenadines and Population (in %) in Uruguay?
Ensure brevity in your answer.  -7.24. In the year 2012, what is the difference between the Population (in %) of Kiribati and Population (in %) of Seychelles?
Make the answer very short. -3.39. In the year 2012, what is the difference between the Population (in %) in Kiribati and Population (in %) in St. Vincent and the Grenadines?
Offer a terse response. -3.32. In the year 2012, what is the difference between the Population (in %) in Kiribati and Population (in %) in Uruguay?
Ensure brevity in your answer.  -10.56. In the year 2012, what is the difference between the Population (in %) in Seychelles and Population (in %) in St. Vincent and the Grenadines?
Ensure brevity in your answer.  0.07. In the year 2012, what is the difference between the Population (in %) in Seychelles and Population (in %) in Uruguay?
Provide a short and direct response. -7.16. In the year 2012, what is the difference between the Population (in %) in St. Vincent and the Grenadines and Population (in %) in Uruguay?
Your response must be concise. -7.23. In the year 2013, what is the difference between the Population (in %) of Kiribati and Population (in %) of Seychelles?
Make the answer very short. -3.26. In the year 2013, what is the difference between the Population (in %) of Kiribati and Population (in %) of St. Vincent and the Grenadines?
Give a very brief answer. -3.42. In the year 2013, what is the difference between the Population (in %) in Kiribati and Population (in %) in Uruguay?
Keep it short and to the point. -10.62. In the year 2013, what is the difference between the Population (in %) in Seychelles and Population (in %) in St. Vincent and the Grenadines?
Make the answer very short. -0.16. In the year 2013, what is the difference between the Population (in %) of Seychelles and Population (in %) of Uruguay?
Provide a short and direct response. -7.36. In the year 2013, what is the difference between the Population (in %) of St. Vincent and the Grenadines and Population (in %) of Uruguay?
Make the answer very short. -7.21. What is the ratio of the Population (in %) of Seychelles in 2006 to that in 2007?
Offer a very short reply. 1. What is the ratio of the Population (in %) in St. Vincent and the Grenadines in 2006 to that in 2007?
Your answer should be very brief. 1.01. What is the ratio of the Population (in %) of Uruguay in 2006 to that in 2007?
Give a very brief answer. 0.99. What is the ratio of the Population (in %) of Kiribati in 2006 to that in 2008?
Offer a very short reply. 1. What is the ratio of the Population (in %) in Seychelles in 2006 to that in 2008?
Make the answer very short. 0.99. What is the ratio of the Population (in %) of St. Vincent and the Grenadines in 2006 to that in 2008?
Your answer should be compact. 1.03. What is the ratio of the Population (in %) of Uruguay in 2006 to that in 2008?
Your answer should be compact. 0.99. What is the ratio of the Population (in %) of Kiribati in 2006 to that in 2009?
Your response must be concise. 1.01. What is the ratio of the Population (in %) in Seychelles in 2006 to that in 2009?
Your answer should be compact. 0.99. What is the ratio of the Population (in %) of St. Vincent and the Grenadines in 2006 to that in 2009?
Your response must be concise. 1.05. What is the ratio of the Population (in %) of Uruguay in 2006 to that in 2009?
Provide a succinct answer. 0.98. What is the ratio of the Population (in %) of Seychelles in 2006 to that in 2010?
Provide a succinct answer. 0.98. What is the ratio of the Population (in %) in St. Vincent and the Grenadines in 2006 to that in 2010?
Your response must be concise. 1.06. What is the ratio of the Population (in %) in Uruguay in 2006 to that in 2010?
Provide a short and direct response. 0.98. What is the ratio of the Population (in %) in Kiribati in 2006 to that in 2011?
Provide a succinct answer. 1.01. What is the ratio of the Population (in %) of St. Vincent and the Grenadines in 2006 to that in 2011?
Ensure brevity in your answer.  1.05. What is the ratio of the Population (in %) of Uruguay in 2006 to that in 2011?
Give a very brief answer. 0.97. What is the ratio of the Population (in %) of Kiribati in 2006 to that in 2012?
Offer a terse response. 1. What is the ratio of the Population (in %) of Seychelles in 2006 to that in 2012?
Give a very brief answer. 1.01. What is the ratio of the Population (in %) in St. Vincent and the Grenadines in 2006 to that in 2012?
Give a very brief answer. 1.03. What is the ratio of the Population (in %) in Uruguay in 2006 to that in 2012?
Offer a terse response. 0.96. What is the ratio of the Population (in %) in Kiribati in 2006 to that in 2013?
Provide a short and direct response. 0.99. What is the ratio of the Population (in %) of Seychelles in 2006 to that in 2013?
Your response must be concise. 1.03. What is the ratio of the Population (in %) in St. Vincent and the Grenadines in 2006 to that in 2013?
Provide a short and direct response. 1.02. What is the ratio of the Population (in %) in Uruguay in 2006 to that in 2013?
Your answer should be very brief. 0.96. What is the ratio of the Population (in %) of Kiribati in 2007 to that in 2008?
Your answer should be very brief. 1. What is the ratio of the Population (in %) in Seychelles in 2007 to that in 2008?
Provide a succinct answer. 0.99. What is the ratio of the Population (in %) of St. Vincent and the Grenadines in 2007 to that in 2008?
Your answer should be very brief. 1.02. What is the ratio of the Population (in %) in Kiribati in 2007 to that in 2009?
Offer a terse response. 1.01. What is the ratio of the Population (in %) in Seychelles in 2007 to that in 2009?
Ensure brevity in your answer.  0.99. What is the ratio of the Population (in %) of St. Vincent and the Grenadines in 2007 to that in 2009?
Offer a terse response. 1.03. What is the ratio of the Population (in %) in Uruguay in 2007 to that in 2009?
Keep it short and to the point. 0.99. What is the ratio of the Population (in %) in Kiribati in 2007 to that in 2010?
Keep it short and to the point. 1.01. What is the ratio of the Population (in %) of Seychelles in 2007 to that in 2010?
Your answer should be very brief. 0.98. What is the ratio of the Population (in %) in St. Vincent and the Grenadines in 2007 to that in 2010?
Provide a short and direct response. 1.05. What is the ratio of the Population (in %) of Uruguay in 2007 to that in 2010?
Your answer should be compact. 0.98. What is the ratio of the Population (in %) of Kiribati in 2007 to that in 2011?
Offer a very short reply. 1. What is the ratio of the Population (in %) in Seychelles in 2007 to that in 2011?
Give a very brief answer. 1. What is the ratio of the Population (in %) of St. Vincent and the Grenadines in 2007 to that in 2011?
Your answer should be very brief. 1.04. What is the ratio of the Population (in %) of Uruguay in 2007 to that in 2011?
Your answer should be compact. 0.98. What is the ratio of the Population (in %) in Seychelles in 2007 to that in 2012?
Offer a very short reply. 1.01. What is the ratio of the Population (in %) of St. Vincent and the Grenadines in 2007 to that in 2012?
Ensure brevity in your answer.  1.02. What is the ratio of the Population (in %) in Uruguay in 2007 to that in 2012?
Your answer should be compact. 0.97. What is the ratio of the Population (in %) in Kiribati in 2007 to that in 2013?
Make the answer very short. 0.99. What is the ratio of the Population (in %) of Seychelles in 2007 to that in 2013?
Provide a short and direct response. 1.03. What is the ratio of the Population (in %) of St. Vincent and the Grenadines in 2007 to that in 2013?
Offer a very short reply. 1. What is the ratio of the Population (in %) in Uruguay in 2007 to that in 2013?
Give a very brief answer. 0.96. What is the ratio of the Population (in %) of Seychelles in 2008 to that in 2009?
Your answer should be very brief. 0.99. What is the ratio of the Population (in %) in St. Vincent and the Grenadines in 2008 to that in 2009?
Your answer should be very brief. 1.02. What is the ratio of the Population (in %) of Uruguay in 2008 to that in 2009?
Ensure brevity in your answer.  0.99. What is the ratio of the Population (in %) of Kiribati in 2008 to that in 2010?
Offer a very short reply. 1. What is the ratio of the Population (in %) in Seychelles in 2008 to that in 2010?
Your answer should be compact. 0.99. What is the ratio of the Population (in %) in St. Vincent and the Grenadines in 2008 to that in 2010?
Make the answer very short. 1.03. What is the ratio of the Population (in %) in Kiribati in 2008 to that in 2011?
Provide a succinct answer. 1. What is the ratio of the Population (in %) in Seychelles in 2008 to that in 2011?
Provide a short and direct response. 1. What is the ratio of the Population (in %) of St. Vincent and the Grenadines in 2008 to that in 2011?
Your answer should be very brief. 1.02. What is the ratio of the Population (in %) of Uruguay in 2008 to that in 2011?
Offer a terse response. 0.98. What is the ratio of the Population (in %) in Seychelles in 2008 to that in 2012?
Ensure brevity in your answer.  1.02. What is the ratio of the Population (in %) in Uruguay in 2008 to that in 2012?
Your answer should be compact. 0.98. What is the ratio of the Population (in %) in Kiribati in 2008 to that in 2013?
Keep it short and to the point. 0.99. What is the ratio of the Population (in %) of Seychelles in 2008 to that in 2013?
Your answer should be compact. 1.03. What is the ratio of the Population (in %) in St. Vincent and the Grenadines in 2008 to that in 2013?
Give a very brief answer. 0.99. What is the ratio of the Population (in %) in Uruguay in 2008 to that in 2013?
Your answer should be compact. 0.97. What is the ratio of the Population (in %) in Kiribati in 2009 to that in 2010?
Offer a very short reply. 1. What is the ratio of the Population (in %) of Seychelles in 2009 to that in 2010?
Provide a short and direct response. 0.99. What is the ratio of the Population (in %) of St. Vincent and the Grenadines in 2009 to that in 2010?
Offer a terse response. 1.01. What is the ratio of the Population (in %) of Uruguay in 2009 to that in 2010?
Offer a very short reply. 0.99. What is the ratio of the Population (in %) in Kiribati in 2009 to that in 2011?
Offer a very short reply. 1. What is the ratio of the Population (in %) in Seychelles in 2009 to that in 2011?
Keep it short and to the point. 1.01. What is the ratio of the Population (in %) of Uruguay in 2009 to that in 2011?
Make the answer very short. 0.99. What is the ratio of the Population (in %) in Seychelles in 2009 to that in 2012?
Your answer should be very brief. 1.02. What is the ratio of the Population (in %) of St. Vincent and the Grenadines in 2009 to that in 2012?
Give a very brief answer. 0.99. What is the ratio of the Population (in %) of Uruguay in 2009 to that in 2012?
Your answer should be very brief. 0.98. What is the ratio of the Population (in %) in Kiribati in 2009 to that in 2013?
Make the answer very short. 0.98. What is the ratio of the Population (in %) of Seychelles in 2009 to that in 2013?
Provide a succinct answer. 1.04. What is the ratio of the Population (in %) of St. Vincent and the Grenadines in 2009 to that in 2013?
Make the answer very short. 0.97. What is the ratio of the Population (in %) of Uruguay in 2009 to that in 2013?
Your response must be concise. 0.97. What is the ratio of the Population (in %) in Kiribati in 2010 to that in 2011?
Your answer should be compact. 1. What is the ratio of the Population (in %) in Seychelles in 2010 to that in 2011?
Offer a terse response. 1.01. What is the ratio of the Population (in %) of St. Vincent and the Grenadines in 2010 to that in 2011?
Provide a succinct answer. 0.99. What is the ratio of the Population (in %) of Uruguay in 2010 to that in 2011?
Provide a succinct answer. 0.99. What is the ratio of the Population (in %) of Kiribati in 2010 to that in 2012?
Provide a short and direct response. 0.99. What is the ratio of the Population (in %) in Seychelles in 2010 to that in 2012?
Offer a very short reply. 1.03. What is the ratio of the Population (in %) of St. Vincent and the Grenadines in 2010 to that in 2012?
Offer a very short reply. 0.98. What is the ratio of the Population (in %) in Uruguay in 2010 to that in 2012?
Your answer should be very brief. 0.99. What is the ratio of the Population (in %) of Kiribati in 2010 to that in 2013?
Offer a terse response. 0.98. What is the ratio of the Population (in %) of Seychelles in 2010 to that in 2013?
Your answer should be compact. 1.04. What is the ratio of the Population (in %) of St. Vincent and the Grenadines in 2010 to that in 2013?
Your response must be concise. 0.96. What is the ratio of the Population (in %) of Uruguay in 2010 to that in 2013?
Your response must be concise. 0.98. What is the ratio of the Population (in %) of St. Vincent and the Grenadines in 2011 to that in 2012?
Give a very brief answer. 0.99. What is the ratio of the Population (in %) of Kiribati in 2011 to that in 2013?
Provide a succinct answer. 0.99. What is the ratio of the Population (in %) in Seychelles in 2011 to that in 2013?
Give a very brief answer. 1.03. What is the ratio of the Population (in %) of St. Vincent and the Grenadines in 2011 to that in 2013?
Your response must be concise. 0.97. What is the ratio of the Population (in %) of Uruguay in 2011 to that in 2013?
Your answer should be very brief. 0.99. What is the ratio of the Population (in %) of Seychelles in 2012 to that in 2013?
Give a very brief answer. 1.01. What is the ratio of the Population (in %) in Uruguay in 2012 to that in 2013?
Ensure brevity in your answer.  0.99. What is the difference between the highest and the second highest Population (in %) in Kiribati?
Keep it short and to the point. 0.03. What is the difference between the highest and the second highest Population (in %) in Seychelles?
Your answer should be compact. 0.04. What is the difference between the highest and the second highest Population (in %) in St. Vincent and the Grenadines?
Give a very brief answer. 0.09. What is the difference between the highest and the second highest Population (in %) of Uruguay?
Make the answer very short. 0.1. What is the difference between the highest and the lowest Population (in %) of Kiribati?
Keep it short and to the point. 0.06. What is the difference between the highest and the lowest Population (in %) of Seychelles?
Your answer should be very brief. 0.3. What is the difference between the highest and the lowest Population (in %) in St. Vincent and the Grenadines?
Your response must be concise. 0.4. What is the difference between the highest and the lowest Population (in %) of Uruguay?
Offer a terse response. 0.61. 